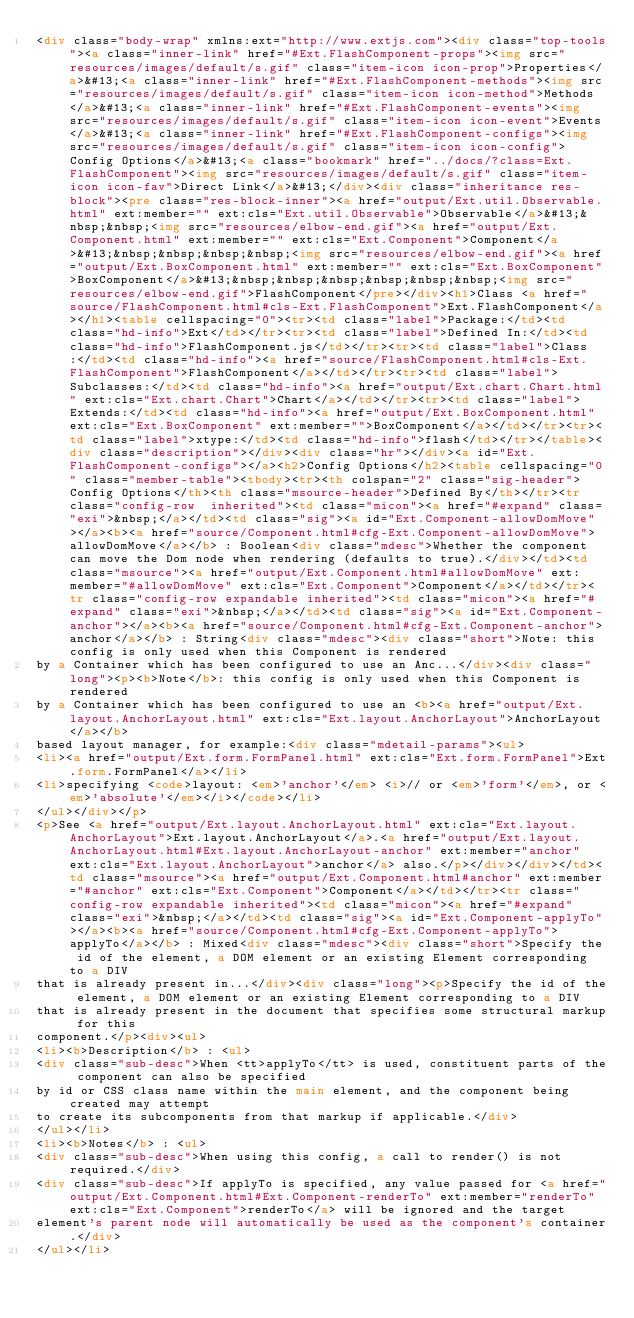<code> <loc_0><loc_0><loc_500><loc_500><_HTML_><div class="body-wrap" xmlns:ext="http://www.extjs.com"><div class="top-tools"><a class="inner-link" href="#Ext.FlashComponent-props"><img src="resources/images/default/s.gif" class="item-icon icon-prop">Properties</a>&#13;<a class="inner-link" href="#Ext.FlashComponent-methods"><img src="resources/images/default/s.gif" class="item-icon icon-method">Methods</a>&#13;<a class="inner-link" href="#Ext.FlashComponent-events"><img src="resources/images/default/s.gif" class="item-icon icon-event">Events</a>&#13;<a class="inner-link" href="#Ext.FlashComponent-configs"><img src="resources/images/default/s.gif" class="item-icon icon-config">Config Options</a>&#13;<a class="bookmark" href="../docs/?class=Ext.FlashComponent"><img src="resources/images/default/s.gif" class="item-icon icon-fav">Direct Link</a>&#13;</div><div class="inheritance res-block"><pre class="res-block-inner"><a href="output/Ext.util.Observable.html" ext:member="" ext:cls="Ext.util.Observable">Observable</a>&#13;&nbsp;&nbsp;<img src="resources/elbow-end.gif"><a href="output/Ext.Component.html" ext:member="" ext:cls="Ext.Component">Component</a>&#13;&nbsp;&nbsp;&nbsp;&nbsp;<img src="resources/elbow-end.gif"><a href="output/Ext.BoxComponent.html" ext:member="" ext:cls="Ext.BoxComponent">BoxComponent</a>&#13;&nbsp;&nbsp;&nbsp;&nbsp;&nbsp;&nbsp;<img src="resources/elbow-end.gif">FlashComponent</pre></div><h1>Class <a href="source/FlashComponent.html#cls-Ext.FlashComponent">Ext.FlashComponent</a></h1><table cellspacing="0"><tr><td class="label">Package:</td><td class="hd-info">Ext</td></tr><tr><td class="label">Defined In:</td><td class="hd-info">FlashComponent.js</td></tr><tr><td class="label">Class:</td><td class="hd-info"><a href="source/FlashComponent.html#cls-Ext.FlashComponent">FlashComponent</a></td></tr><tr><td class="label">Subclasses:</td><td class="hd-info"><a href="output/Ext.chart.Chart.html" ext:cls="Ext.chart.Chart">Chart</a></td></tr><tr><td class="label">Extends:</td><td class="hd-info"><a href="output/Ext.BoxComponent.html" ext:cls="Ext.BoxComponent" ext:member="">BoxComponent</a></td></tr><tr><td class="label">xtype:</td><td class="hd-info">flash</td></tr></table><div class="description"></div><div class="hr"></div><a id="Ext.FlashComponent-configs"></a><h2>Config Options</h2><table cellspacing="0" class="member-table"><tbody><tr><th colspan="2" class="sig-header">Config Options</th><th class="msource-header">Defined By</th></tr><tr class="config-row  inherited"><td class="micon"><a href="#expand" class="exi">&nbsp;</a></td><td class="sig"><a id="Ext.Component-allowDomMove"></a><b><a href="source/Component.html#cfg-Ext.Component-allowDomMove">allowDomMove</a></b> : Boolean<div class="mdesc">Whether the component can move the Dom node when rendering (defaults to true).</div></td><td class="msource"><a href="output/Ext.Component.html#allowDomMove" ext:member="#allowDomMove" ext:cls="Ext.Component">Component</a></td></tr><tr class="config-row expandable inherited"><td class="micon"><a href="#expand" class="exi">&nbsp;</a></td><td class="sig"><a id="Ext.Component-anchor"></a><b><a href="source/Component.html#cfg-Ext.Component-anchor">anchor</a></b> : String<div class="mdesc"><div class="short">Note: this config is only used when this Component is rendered
by a Container which has been configured to use an Anc...</div><div class="long"><p><b>Note</b>: this config is only used when this Component is rendered
by a Container which has been configured to use an <b><a href="output/Ext.layout.AnchorLayout.html" ext:cls="Ext.layout.AnchorLayout">AnchorLayout</a></b>
based layout manager, for example:<div class="mdetail-params"><ul>
<li><a href="output/Ext.form.FormPanel.html" ext:cls="Ext.form.FormPanel">Ext.form.FormPanel</a></li>
<li>specifying <code>layout: <em>'anchor'</em> <i>// or <em>'form'</em>, or <em>'absolute'</em></i></code></li>
</ul></div></p>
<p>See <a href="output/Ext.layout.AnchorLayout.html" ext:cls="Ext.layout.AnchorLayout">Ext.layout.AnchorLayout</a>.<a href="output/Ext.layout.AnchorLayout.html#Ext.layout.AnchorLayout-anchor" ext:member="anchor" ext:cls="Ext.layout.AnchorLayout">anchor</a> also.</p></div></div></td><td class="msource"><a href="output/Ext.Component.html#anchor" ext:member="#anchor" ext:cls="Ext.Component">Component</a></td></tr><tr class="config-row expandable inherited"><td class="micon"><a href="#expand" class="exi">&nbsp;</a></td><td class="sig"><a id="Ext.Component-applyTo"></a><b><a href="source/Component.html#cfg-Ext.Component-applyTo">applyTo</a></b> : Mixed<div class="mdesc"><div class="short">Specify the id of the element, a DOM element or an existing Element corresponding to a DIV
that is already present in...</div><div class="long"><p>Specify the id of the element, a DOM element or an existing Element corresponding to a DIV
that is already present in the document that specifies some structural markup for this
component.</p><div><ul>
<li><b>Description</b> : <ul>
<div class="sub-desc">When <tt>applyTo</tt> is used, constituent parts of the component can also be specified
by id or CSS class name within the main element, and the component being created may attempt
to create its subcomponents from that markup if applicable.</div>
</ul></li>
<li><b>Notes</b> : <ul>
<div class="sub-desc">When using this config, a call to render() is not required.</div>
<div class="sub-desc">If applyTo is specified, any value passed for <a href="output/Ext.Component.html#Ext.Component-renderTo" ext:member="renderTo" ext:cls="Ext.Component">renderTo</a> will be ignored and the target
element's parent node will automatically be used as the component's container.</div>
</ul></li></code> 